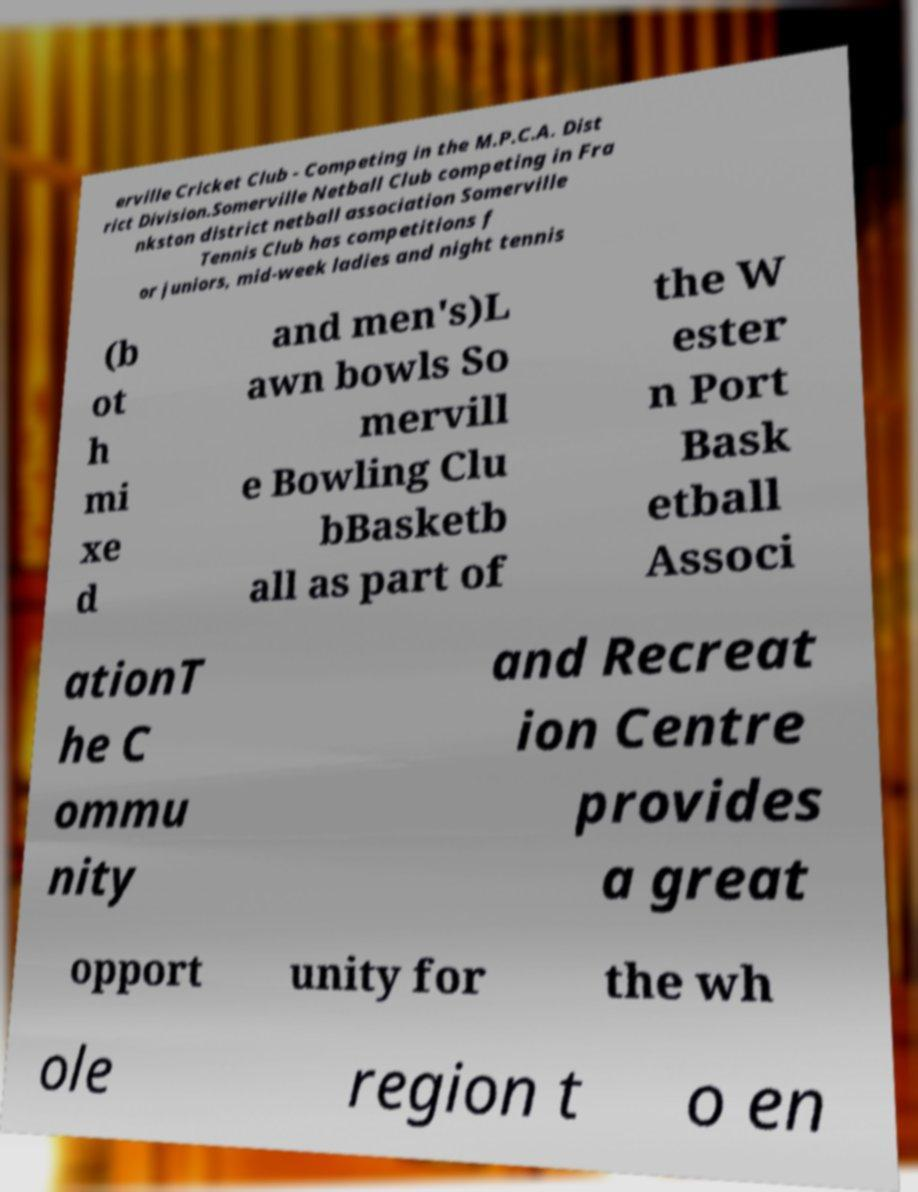What messages or text are displayed in this image? I need them in a readable, typed format. erville Cricket Club - Competing in the M.P.C.A. Dist rict Division.Somerville Netball Club competing in Fra nkston district netball association Somerville Tennis Club has competitions f or juniors, mid-week ladies and night tennis (b ot h mi xe d and men's)L awn bowls So mervill e Bowling Clu bBasketb all as part of the W ester n Port Bask etball Associ ationT he C ommu nity and Recreat ion Centre provides a great opport unity for the wh ole region t o en 